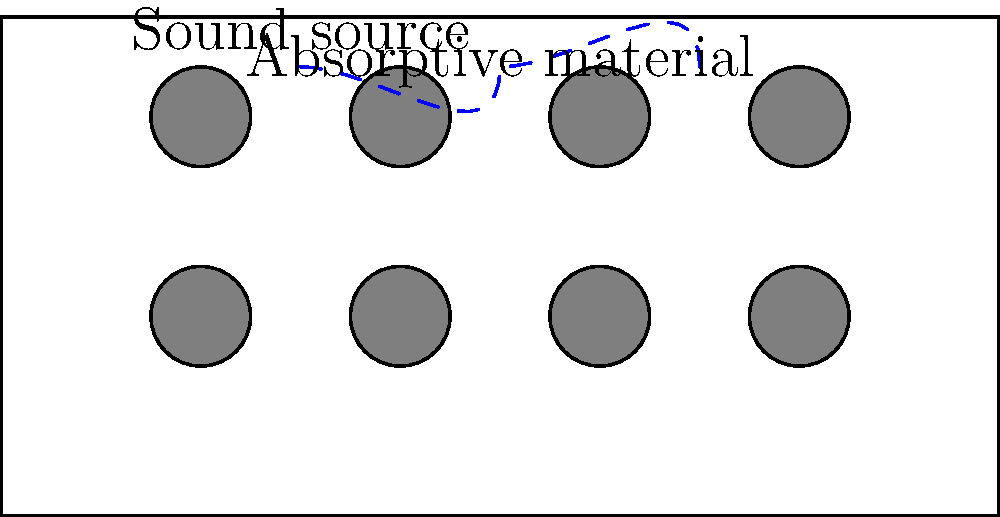In your bustling restaurant, you've noticed that the noise level is affecting customer experience. To address this, you're considering adding sound-absorbing materials to the ceiling. If the average sound intensity level in the dining area is 75 dB, and you want to reduce it to 65 dB, what percentage of sound energy needs to be absorbed by the new materials? To solve this problem, we'll follow these steps:

1. Recall the relationship between sound intensity level (SIL) and sound intensity (I):
   $SIL = 10 \log_{10}(\frac{I}{I_0})$ where $I_0 = 10^{-12} W/m^2$

2. Let $I_1$ be the initial intensity and $I_2$ be the final intensity.
   For the initial 75 dB: $75 = 10 \log_{10}(\frac{I_1}{I_0})$
   For the final 65 dB: $65 = 10 \log_{10}(\frac{I_2}{I_0})$

3. Solve for $I_1$ and $I_2$:
   $I_1 = I_0 \cdot 10^{7.5} = 10^{-12} \cdot 10^{7.5} = 10^{-4.5} W/m^2$
   $I_2 = I_0 \cdot 10^{6.5} = 10^{-12} \cdot 10^{6.5} = 10^{-5.5} W/m^2$

4. Calculate the fraction of intensity that needs to be absorbed:
   Fraction absorbed = $\frac{I_1 - I_2}{I_1} = \frac{10^{-4.5} - 10^{-5.5}}{10^{-4.5}}$

5. Simplify:
   $\frac{10^{-4.5} - 10^{-5.5}}{10^{-4.5}} = 1 - \frac{10^{-5.5}}{10^{-4.5}} = 1 - 10^{-1} = 0.9$

6. Convert to percentage:
   0.9 × 100% = 90%

Therefore, the new materials need to absorb 90% of the sound energy to reduce the sound intensity level from 75 dB to 65 dB.
Answer: 90% 